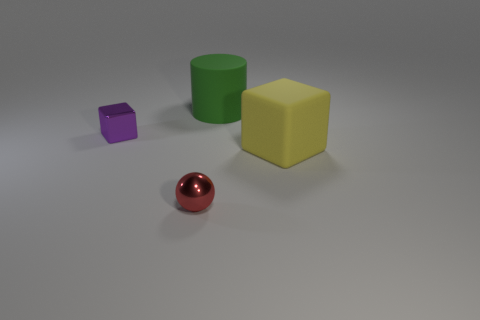There is a large rubber thing in front of the small purple object; is its shape the same as the metallic object that is on the left side of the tiny red metallic object?
Offer a terse response. Yes. Is the number of purple objects that are on the left side of the tiny purple block the same as the number of large green metal cylinders?
Keep it short and to the point. Yes. How many large cubes have the same material as the large cylinder?
Make the answer very short. 1. There is another thing that is the same material as the tiny red object; what is its color?
Your answer should be very brief. Purple. There is a shiny block; is it the same size as the object that is in front of the big yellow matte thing?
Your response must be concise. Yes. The red metallic object has what shape?
Make the answer very short. Sphere. What is the color of the other big object that is the same shape as the purple metallic object?
Your answer should be compact. Yellow. How many large blocks are behind the tiny metallic object left of the red thing?
Your answer should be very brief. 0. How many blocks are either small red things or yellow things?
Provide a succinct answer. 1. Are any blue rubber spheres visible?
Provide a short and direct response. No. 